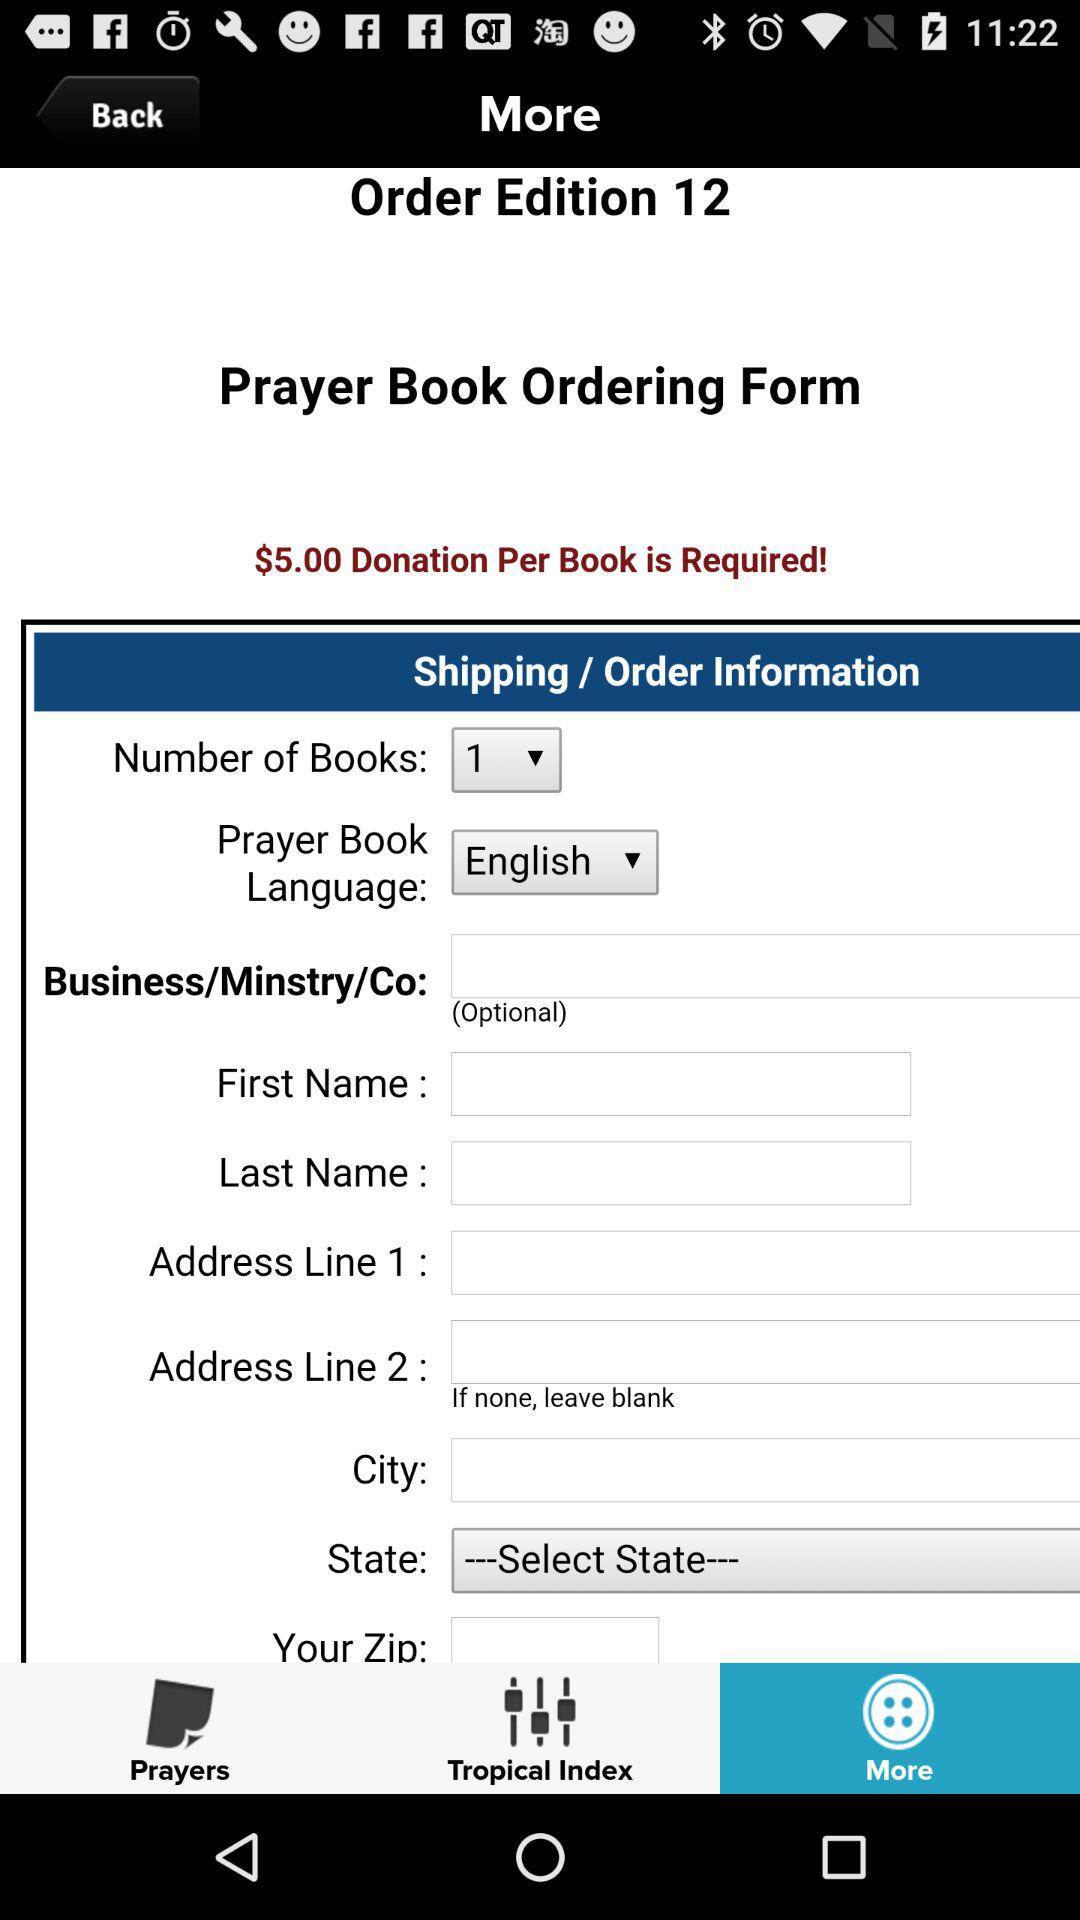What is the selected tab? The selected tab is "More". 